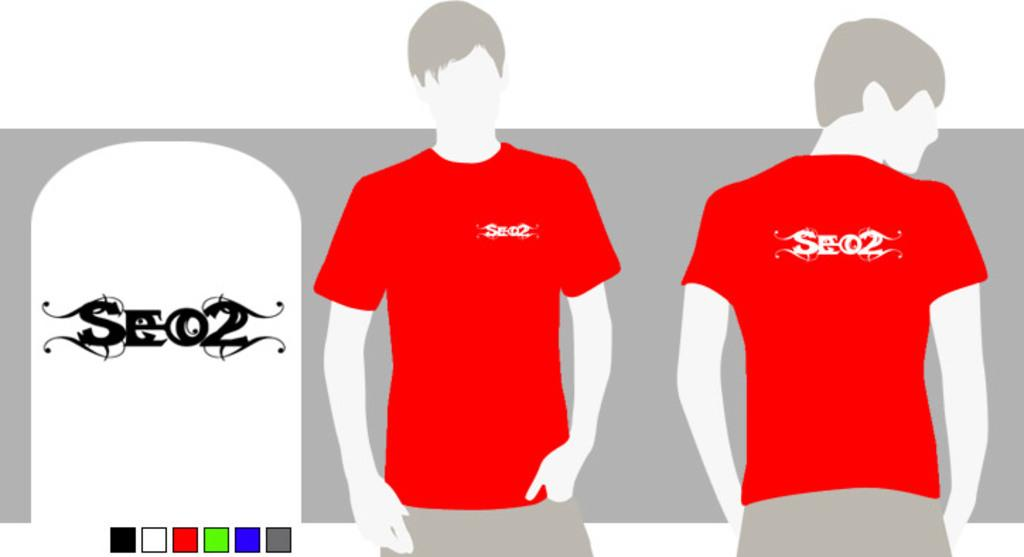<image>
Give a short and clear explanation of the subsequent image. A graphic for a shirt taht reads SE 02 